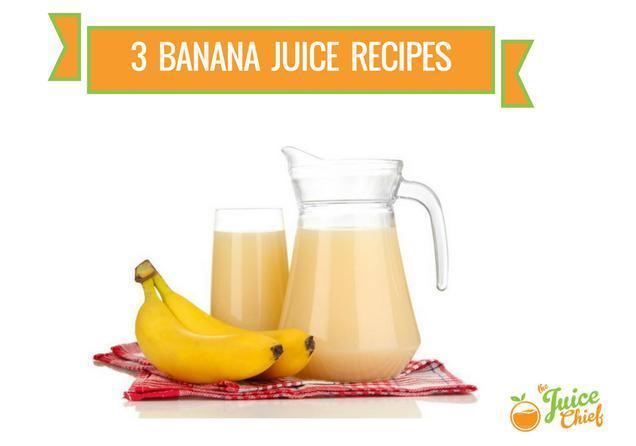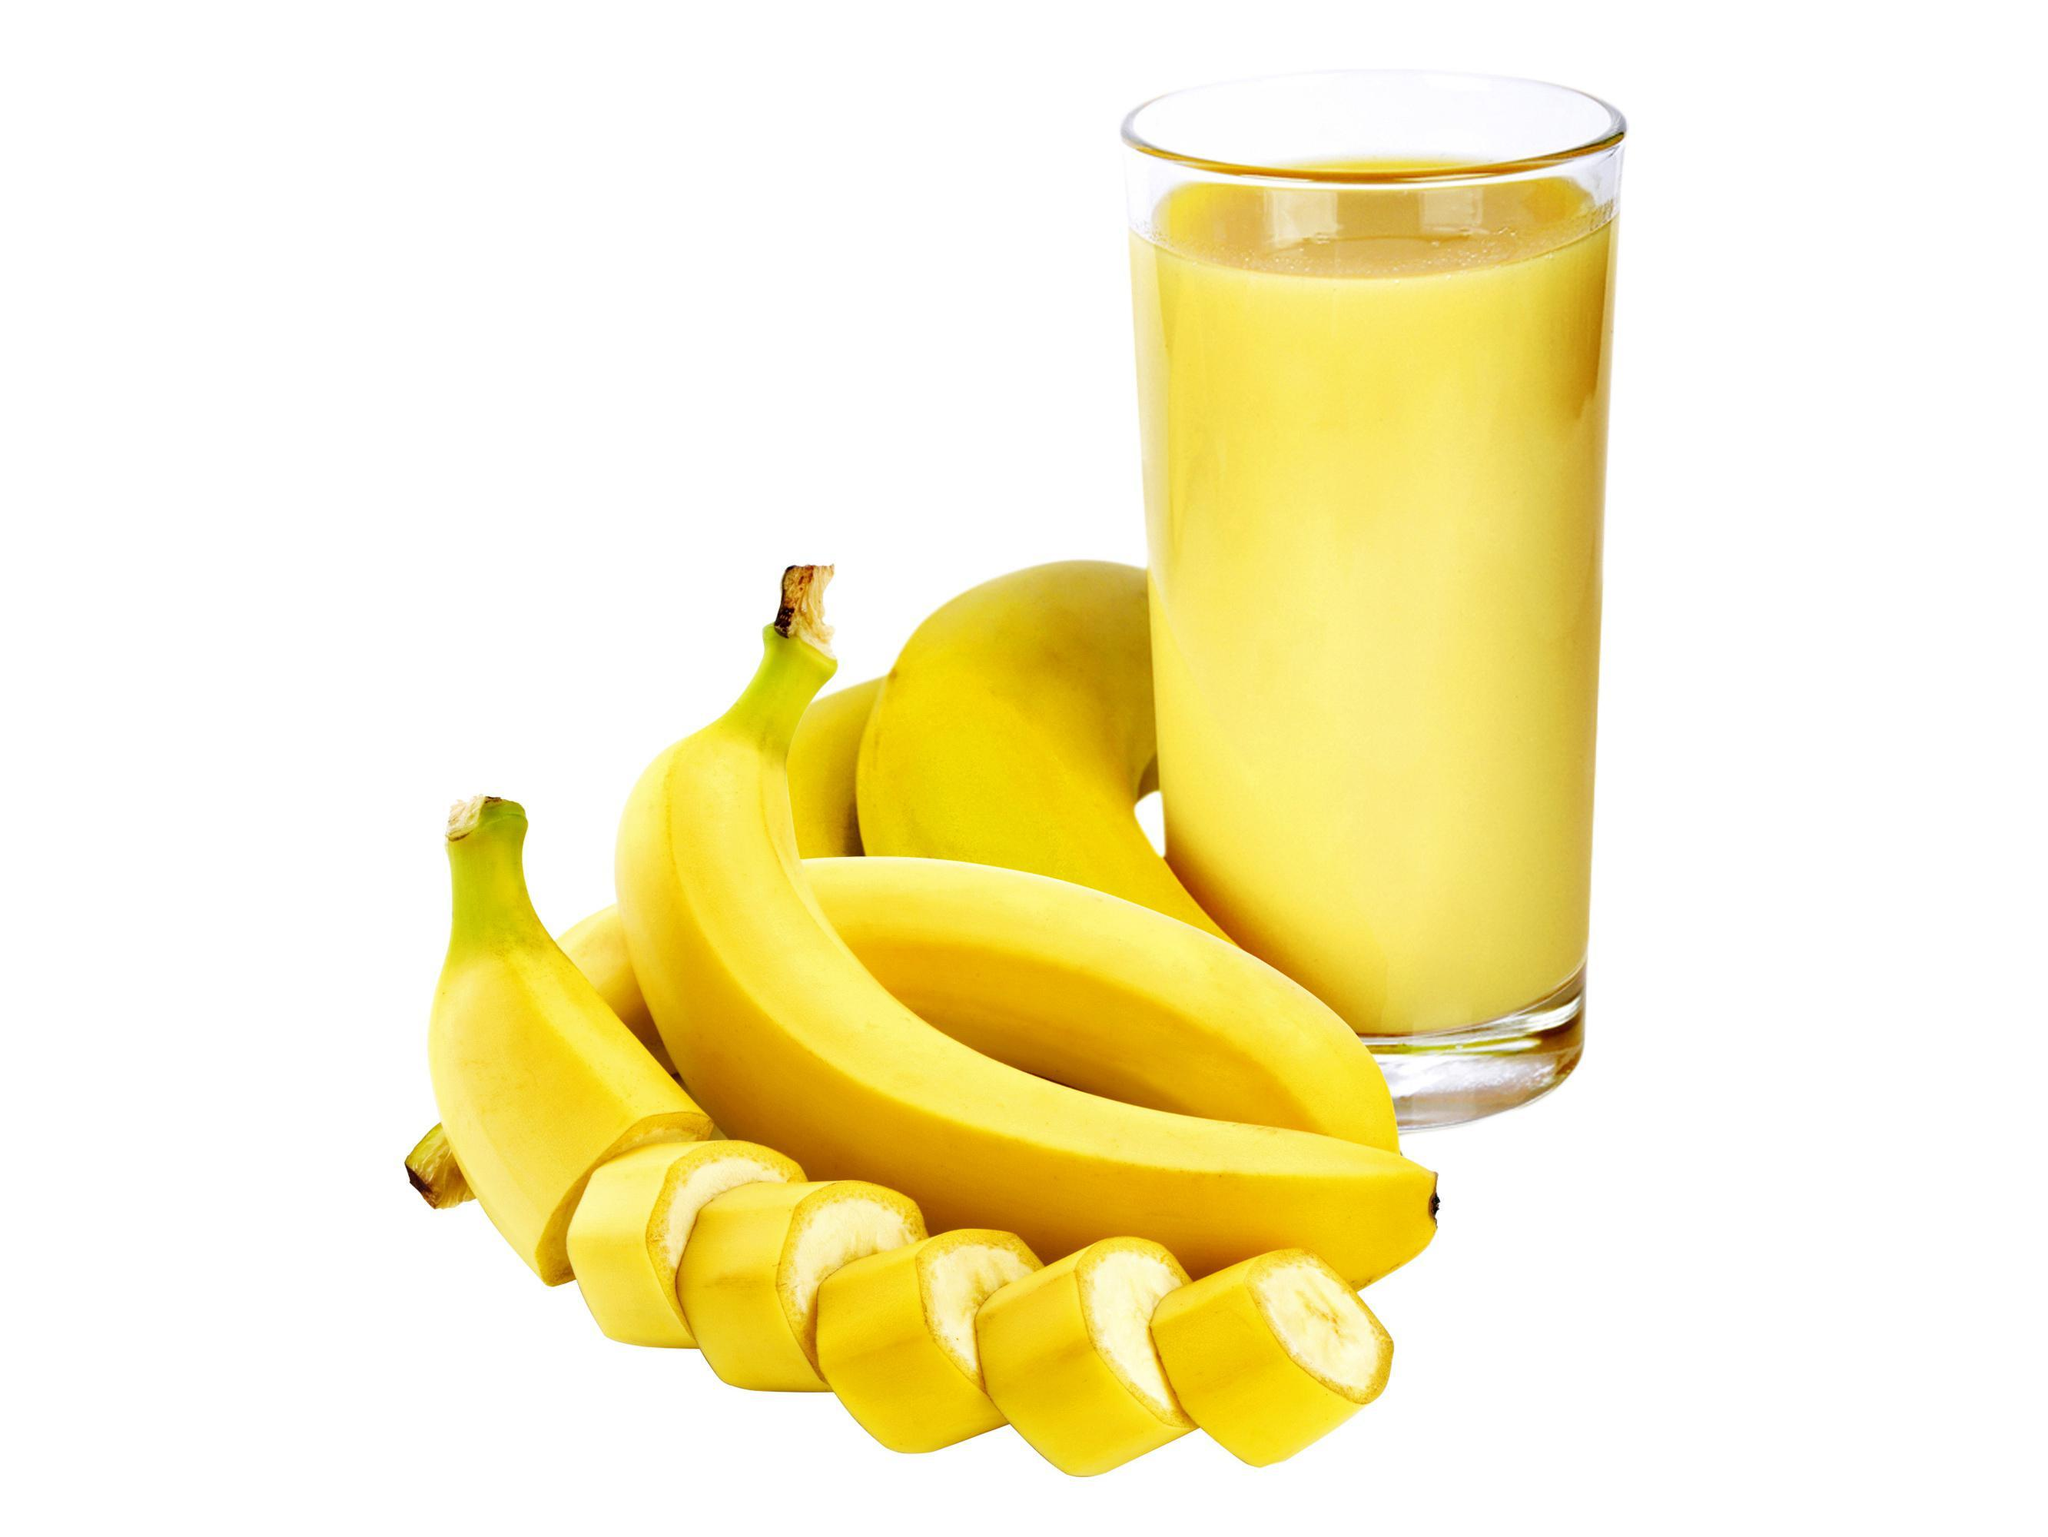The first image is the image on the left, the second image is the image on the right. Assess this claim about the two images: "The right image contains no more than one orange and one banana next to two smoothies.". Correct or not? Answer yes or no. No. The first image is the image on the left, the second image is the image on the right. Evaluate the accuracy of this statement regarding the images: "A pitcher and a glass of the same beverage are behind a small bunch of bananas.". Is it true? Answer yes or no. Yes. 